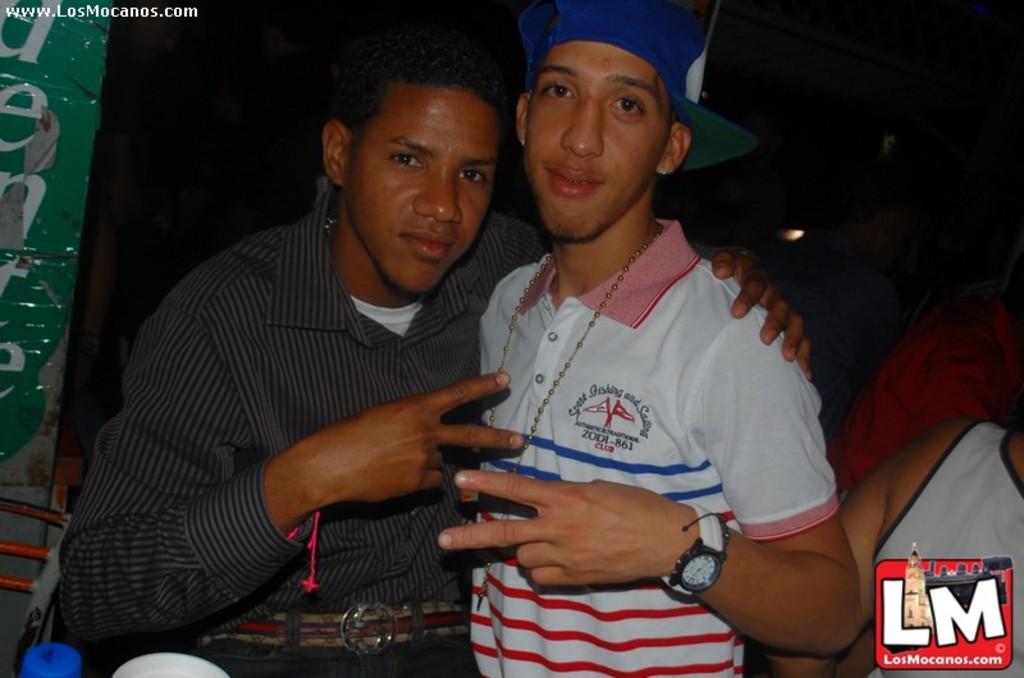What is the letters in the bottom right?
Keep it short and to the point. Lm. 